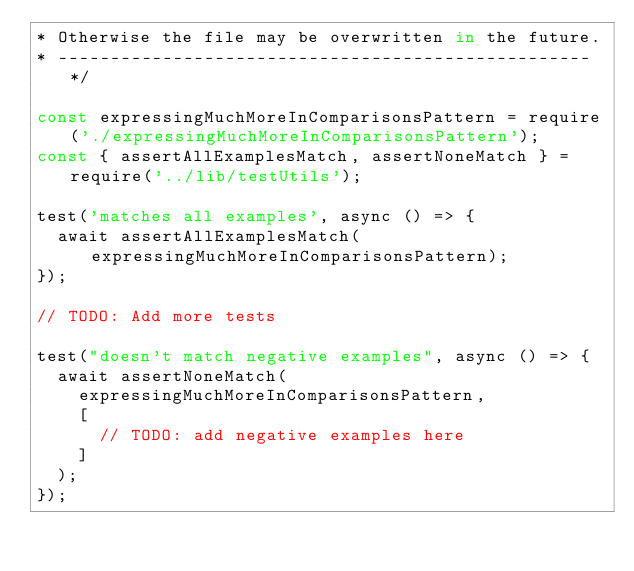<code> <loc_0><loc_0><loc_500><loc_500><_JavaScript_>* Otherwise the file may be overwritten in the future.
* --------------------------------------------------- */

const expressingMuchMoreInComparisonsPattern = require('./expressingMuchMoreInComparisonsPattern');
const { assertAllExamplesMatch, assertNoneMatch } = require('../lib/testUtils');

test('matches all examples', async () => {
  await assertAllExamplesMatch(expressingMuchMoreInComparisonsPattern);
});

// TODO: Add more tests

test("doesn't match negative examples", async () => {
  await assertNoneMatch(
    expressingMuchMoreInComparisonsPattern,
    [
      // TODO: add negative examples here
    ]
  );
});
</code> 